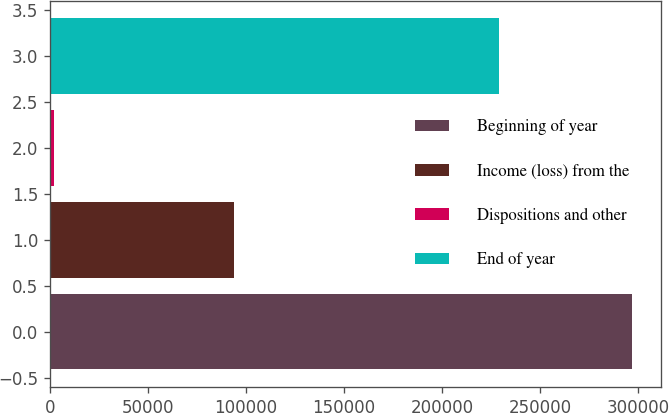<chart> <loc_0><loc_0><loc_500><loc_500><bar_chart><fcel>Beginning of year<fcel>Income (loss) from the<fcel>Dispositions and other<fcel>End of year<nl><fcel>296784<fcel>93744<fcel>2258<fcel>229089<nl></chart> 